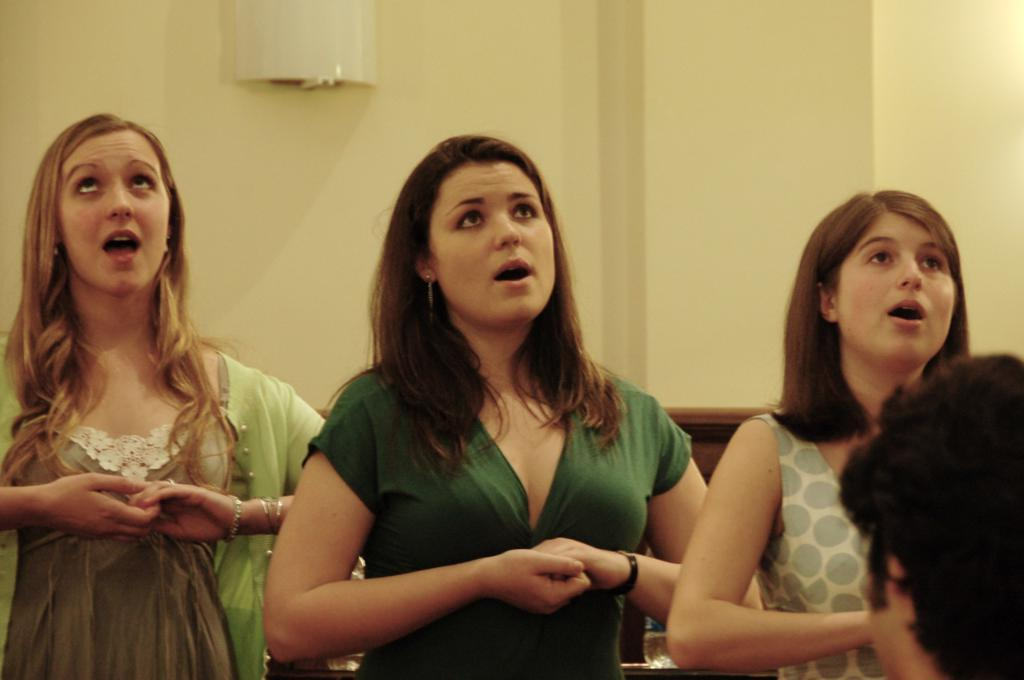What is happening in the image? There is a group of women standing in the image. What can be seen in the background of the image? There is an object on a wall in the background of the image. Can you describe the head visible on the right side of the image? The head of a person is visible on the right side of the image. What type of meat is being used as bait in the image? There is no meat or bait present in the image. 